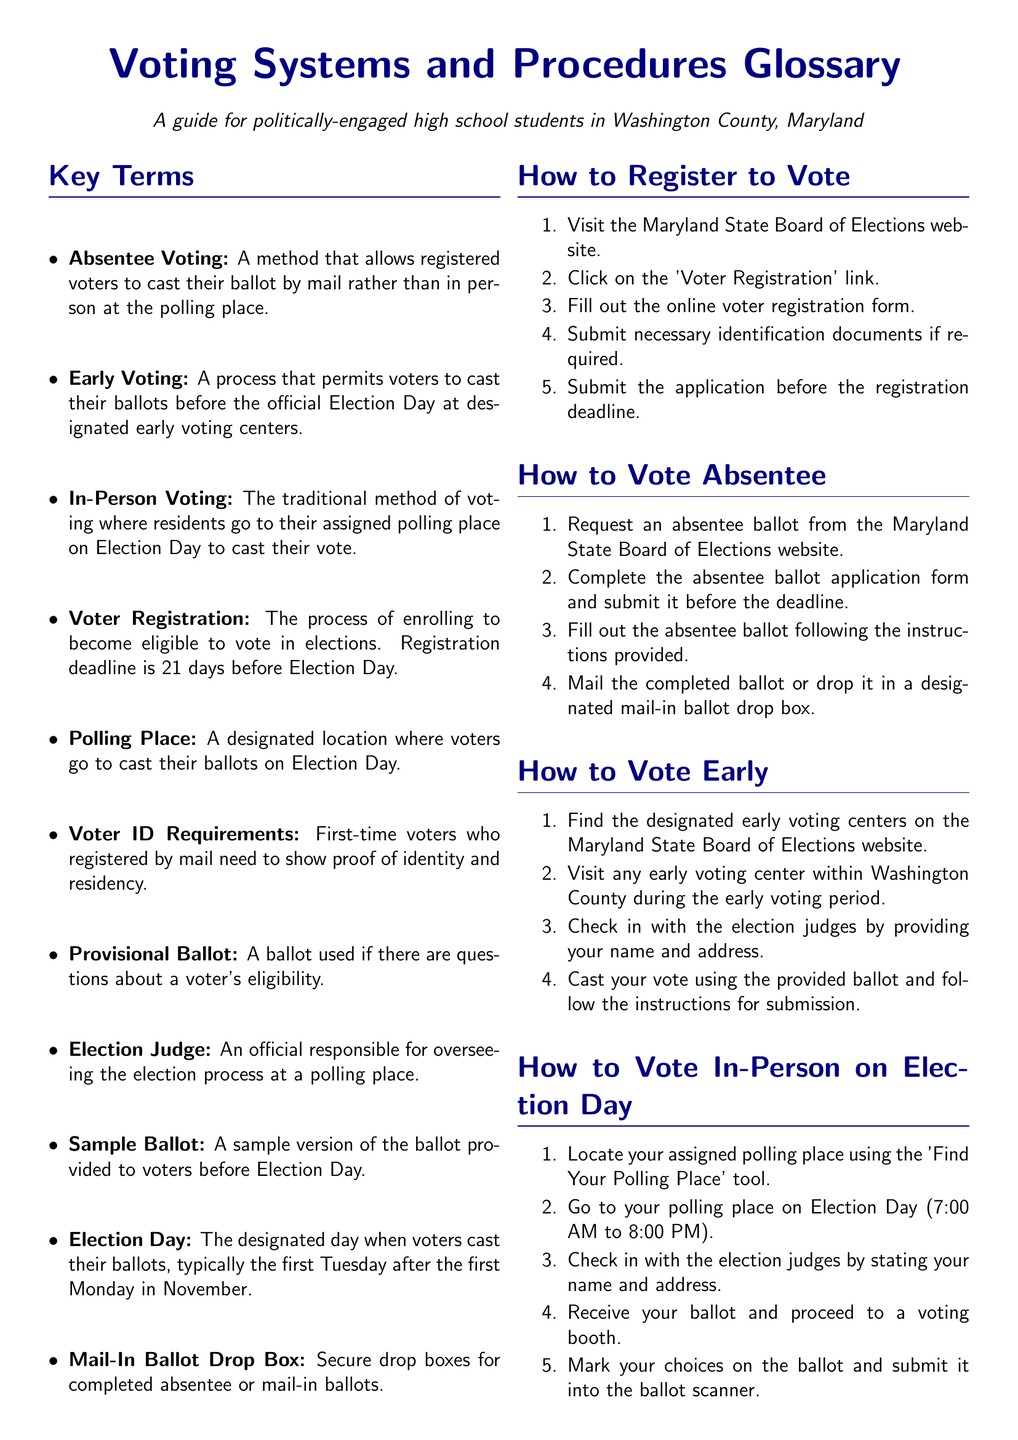What is the deadline for voter registration? The document states that the voter registration deadline is 21 days before Election Day.
Answer: 21 days What is absentee voting? Absentee voting is defined as a method that allows registered voters to cast their ballot by mail rather than in person at the polling place.
Answer: A method to vote by mail What do you need to show as a first-time voter registered by mail? The document indicates that first-time voters who registered by mail need to show proof of identity and residency.
Answer: Proof of identity and residency How do you vote in-person on Election Day? The document lists multiple steps such as locating your polling place, going there, checking in, receiving your ballot, and submitting it.
Answer: Go to your polling place and follow the steps What is the last step in the absentee voting process? The final step in the absentee voting process is to mail the completed ballot or drop it in a designated mail-in ballot drop box.
Answer: Mail the completed ballot What time does polling open on Election Day? According to the document, polling opens at 7:00 AM on Election Day.
Answer: 7:00 AM How many steps are there to register to vote? The document outlines a total of five steps for registering to vote.
Answer: Five steps Where can you find a sample ballot? The document mentions that a sample ballot is provided to voters before Election Day.
Answer: Provided before Election Day 